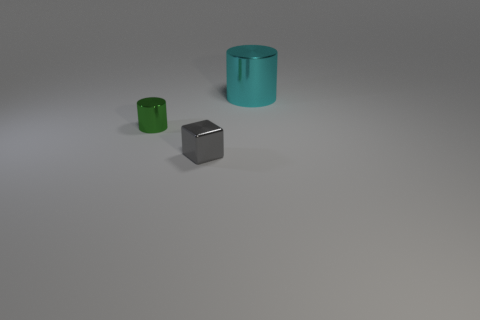Is there anything else that has the same size as the cyan metal object?
Your answer should be compact. No. How big is the cyan metallic cylinder?
Your answer should be very brief. Large. What number of rubber things are large blue spheres or big cylinders?
Your answer should be compact. 0. Are there fewer metal cylinders than metal things?
Your answer should be very brief. Yes. What number of other things are made of the same material as the big cyan cylinder?
Your answer should be compact. 2. There is another green metallic thing that is the same shape as the big thing; what is its size?
Give a very brief answer. Small. Are the cylinder in front of the big metal cylinder and the small thing that is on the right side of the tiny cylinder made of the same material?
Give a very brief answer. Yes. Is the number of blocks to the right of the cyan cylinder less than the number of green things?
Give a very brief answer. Yes. Are there any other things that have the same shape as the small green thing?
Give a very brief answer. Yes. What color is the other shiny object that is the same shape as the large cyan object?
Your answer should be compact. Green. 